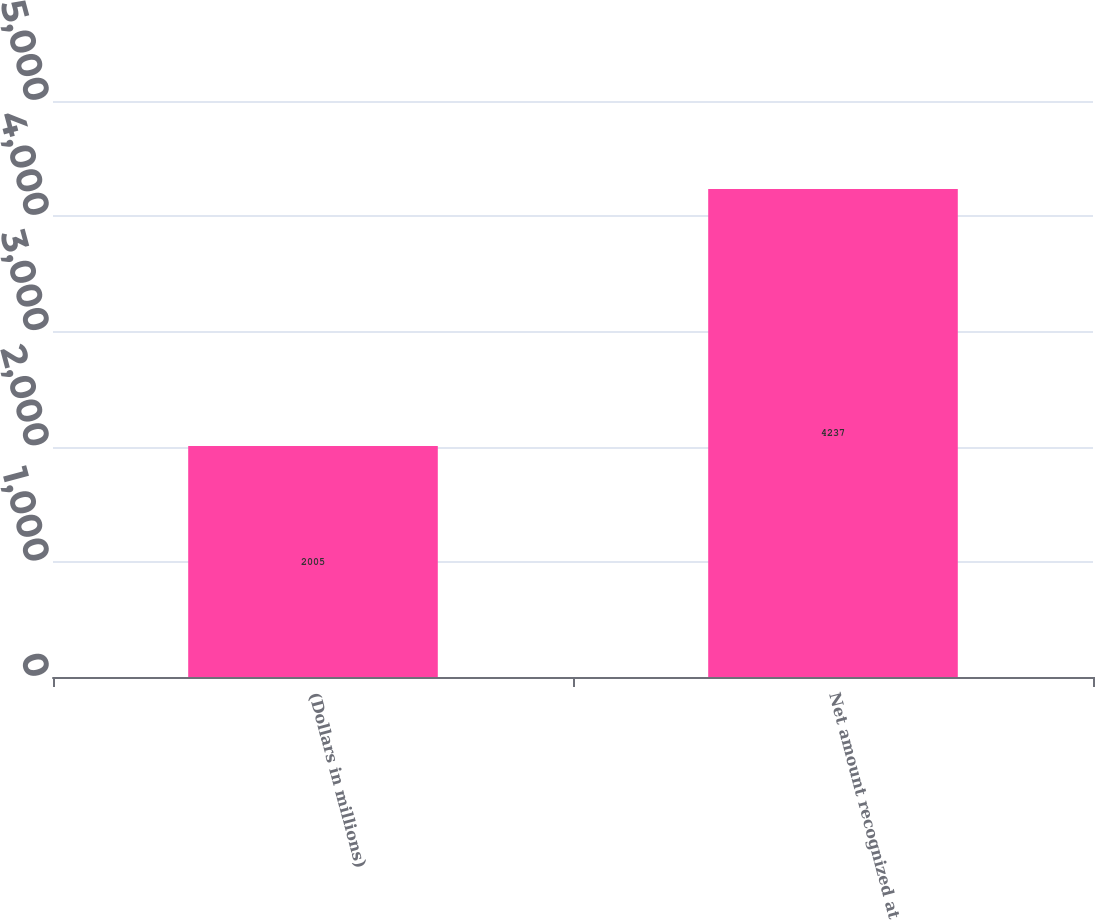Convert chart. <chart><loc_0><loc_0><loc_500><loc_500><bar_chart><fcel>(Dollars in millions)<fcel>Net amount recognized at<nl><fcel>2005<fcel>4237<nl></chart> 